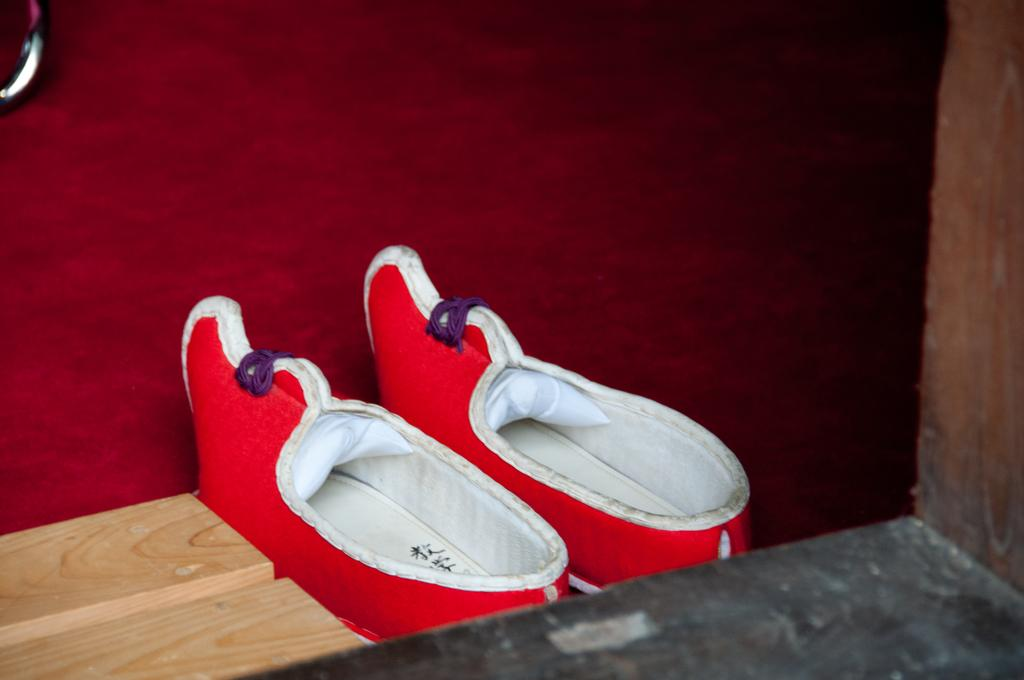What is placed on the floor in the image? There is a pair of shoes on the floor in the image. What can be seen on the left side of the image? There is a wooden block on the left side of the image. What type of dinner is being served on the wooden block in the image? There is no dinner or food present on the wooden block in the image; it is a standalone object. Can you describe the head of the person in the image? There is no person present in the image, so it is not possible to describe their head. 